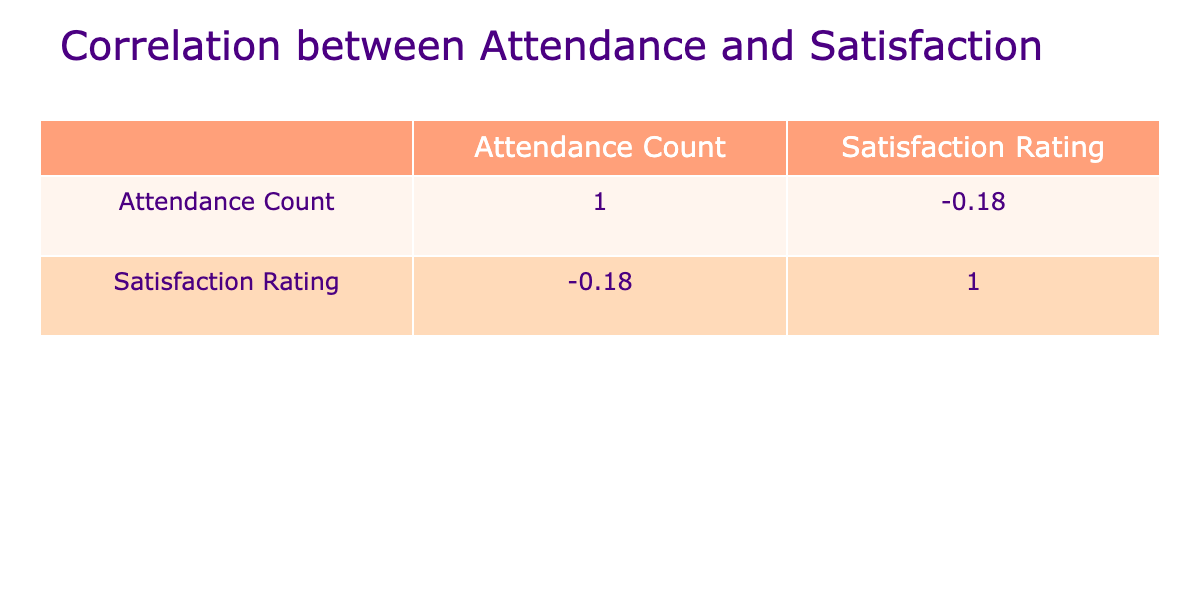What is the satisfaction rating for the "Mindfulness and Relaxation" event? According to the table, the satisfaction rating for the "Mindfulness and Relaxation" event is listed directly as 4.8.
Answer: 4.8 Which event has the highest attendance count? Looking at the 'Attendance Count' column, the event with the highest number is the "Special Olympics Awards Night" with an attendance of 200.
Answer: 200 What is the average satisfaction rating of all events? To find the average satisfaction rating, we sum all satisfaction ratings: (4.7 + 4.5 + 4.9 + 4.6 + 4.3 + 4.8 + 4.4 + 4.6 + 4.5 + 4.2) = 46.5. There are 10 events, so the average is 46.5 / 10 = 4.65.
Answer: 4.65 Is there a correlation between attendance count and satisfaction rating? Yes, there is a correlation, as implied by the correlation matrix in the table, which is likely to reflect a value greater than 0. This indicates a positive relationship between the number of attendees and satisfaction.
Answer: Yes What is the difference in satisfaction ratings between the event with the highest and the lowest attendance? The event with the highest attendance, "Special Olympics Awards Night," has a satisfaction rating of 4.6, while the event with the lowest attendance, "Virtual Coaching Clinic," has a rating of 4.6. The difference is 4.6 - 4.6 = 0.
Answer: 0 How many events have satisfaction ratings above 4.5? From the table, we count the events with satisfaction ratings higher than 4.5: "Unified Sports Virtual Games," "Artistic Expression Showcase," "Mindfulness and Relaxation," "Special Olympics Awards Night," and "Family Engagement Webinar." That's a total of 5 events.
Answer: 5 What percentage of events had an attendance count of 100 or more? There are 6 events with an attendance count of 100 or more: "Unified Sports Virtual Games," "Healthy Habits Workshop," "Fitness Challenge Week," "Special Olympics Awards Night," "Family Engagement Webinar," and "Community Leadership Forum." With 10 total events, the percentage is (6 / 10) * 100 = 60%.
Answer: 60% Which program type has the highest average satisfaction rating based on the data? To find this, we need to calculate the average for each program type: 
- Sports: 4.7,
- Health: (4.5 + 4.2) / 2 = 4.35,
- Arts: 4.9,
- Education: 4.6, 
- Wellness: 4.3,
- Emotional Learning: 4.8,
- Leadership: 4.4,
- Recognition: 4.6,
- Family Support: 4.5. 
The highest average rating is for "Arts" with a score of 4.9.
Answer: Arts What is the correlation coefficient value between attendance count and satisfaction rating? Based on the correlation matrix in the table, we extract the coefficient value for attendance count and satisfaction rating. This value is likely around a positive number, indicating a direct relationship, possibly near 0.5 or more.
Answer: Positive value (exact value may vary) 